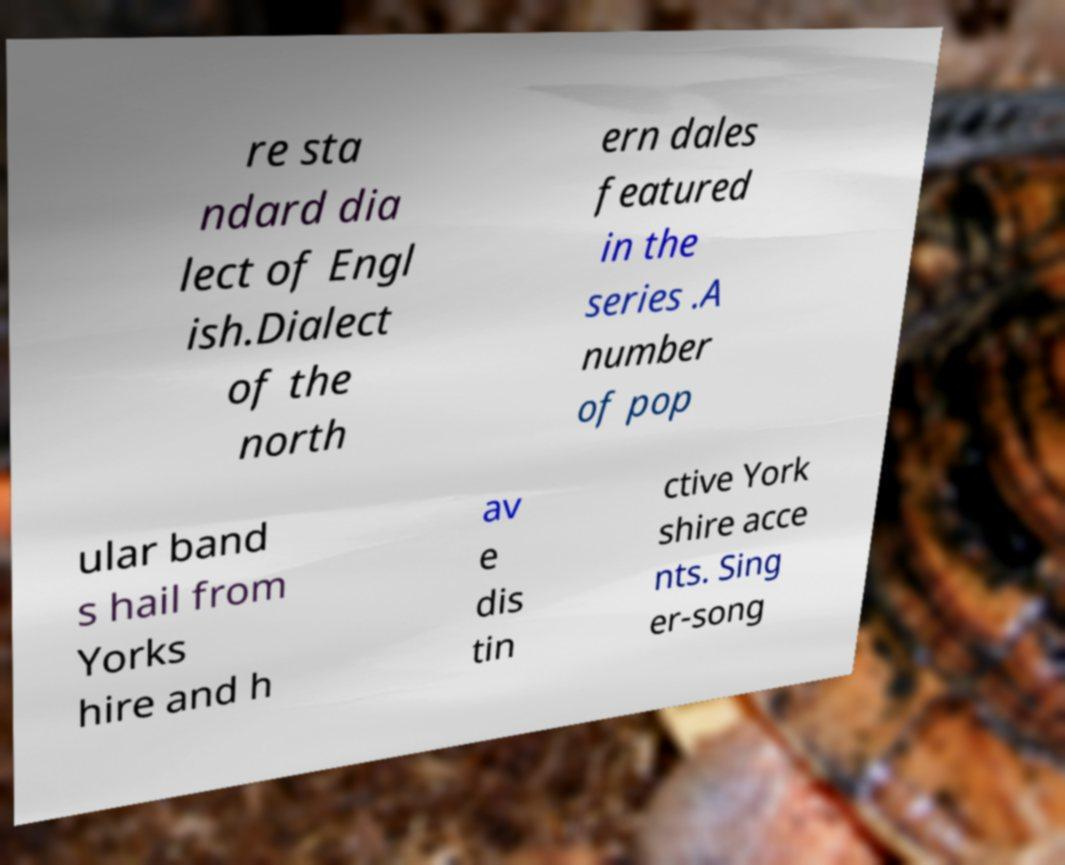Please read and relay the text visible in this image. What does it say? re sta ndard dia lect of Engl ish.Dialect of the north ern dales featured in the series .A number of pop ular band s hail from Yorks hire and h av e dis tin ctive York shire acce nts. Sing er-song 